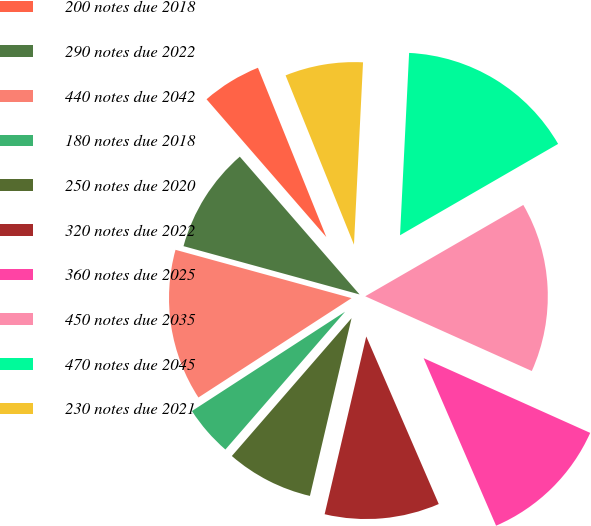Convert chart. <chart><loc_0><loc_0><loc_500><loc_500><pie_chart><fcel>200 notes due 2018<fcel>290 notes due 2022<fcel>440 notes due 2042<fcel>180 notes due 2018<fcel>250 notes due 2020<fcel>320 notes due 2022<fcel>360 notes due 2025<fcel>450 notes due 2035<fcel>470 notes due 2045<fcel>230 notes due 2021<nl><fcel>5.28%<fcel>9.35%<fcel>13.42%<fcel>4.46%<fcel>7.72%<fcel>10.16%<fcel>11.79%<fcel>15.05%<fcel>15.87%<fcel>6.9%<nl></chart> 